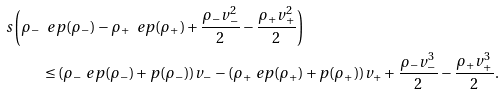<formula> <loc_0><loc_0><loc_500><loc_500>s \left ( \rho _ { - } \ e p ( \rho _ { - } ) - \rho _ { + } \ e p ( \rho _ { + } ) + \frac { \rho _ { - } v _ { - } ^ { 2 } } { 2 } - \frac { \rho _ { + } v _ { + } ^ { 2 } } { 2 } \right ) & \\ \leq ( \rho _ { - } \ e p ( \rho _ { - } ) + p ( \rho _ { - } ) ) v _ { - } - ( \rho _ { + } \ e p ( \rho _ { + } ) & + p ( \rho _ { + } ) ) v _ { + } + \frac { \rho _ { - } v _ { - } ^ { 3 } } { 2 } - \frac { \rho _ { + } v _ { + } ^ { 3 } } { 2 } .</formula> 